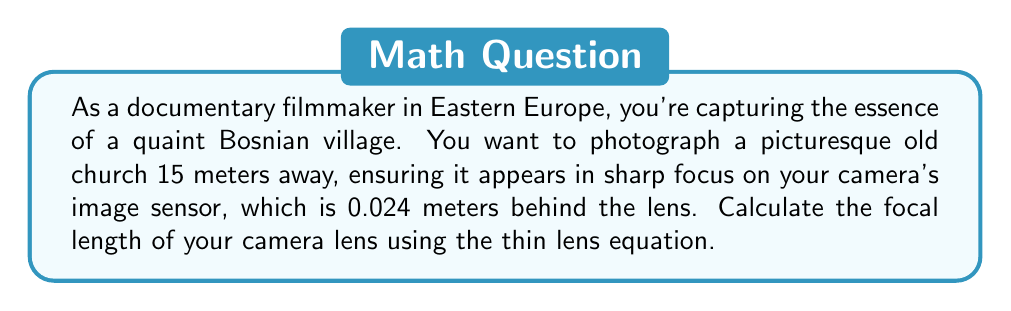Show me your answer to this math problem. Let's approach this step-by-step using the thin lens equation:

1) The thin lens equation is:

   $$\frac{1}{f} = \frac{1}{d_o} + \frac{1}{d_i}$$

   Where:
   $f$ = focal length
   $d_o$ = distance to object
   $d_i$ = distance to image

2) We know:
   $d_o = 15$ meters (distance to the church)
   $d_i = 0.024$ meters (distance from lens to image sensor)

3) Let's substitute these values into the equation:

   $$\frac{1}{f} = \frac{1}{15} + \frac{1}{0.024}$$

4) Now, let's solve for $f$:

   $$\frac{1}{f} = 0.0667 + 41.6667 = 41.7334$$

5) To get $f$ by itself, we take the reciprocal of both sides:

   $$f = \frac{1}{41.7334}$$

6) Calculate the final value:

   $$f = 0.02396 \text{ meters}$$

7) Convert to millimeters for a more common lens measurement:

   $$f = 23.96 \text{ mm}$$
Answer: $23.96 \text{ mm}$ 